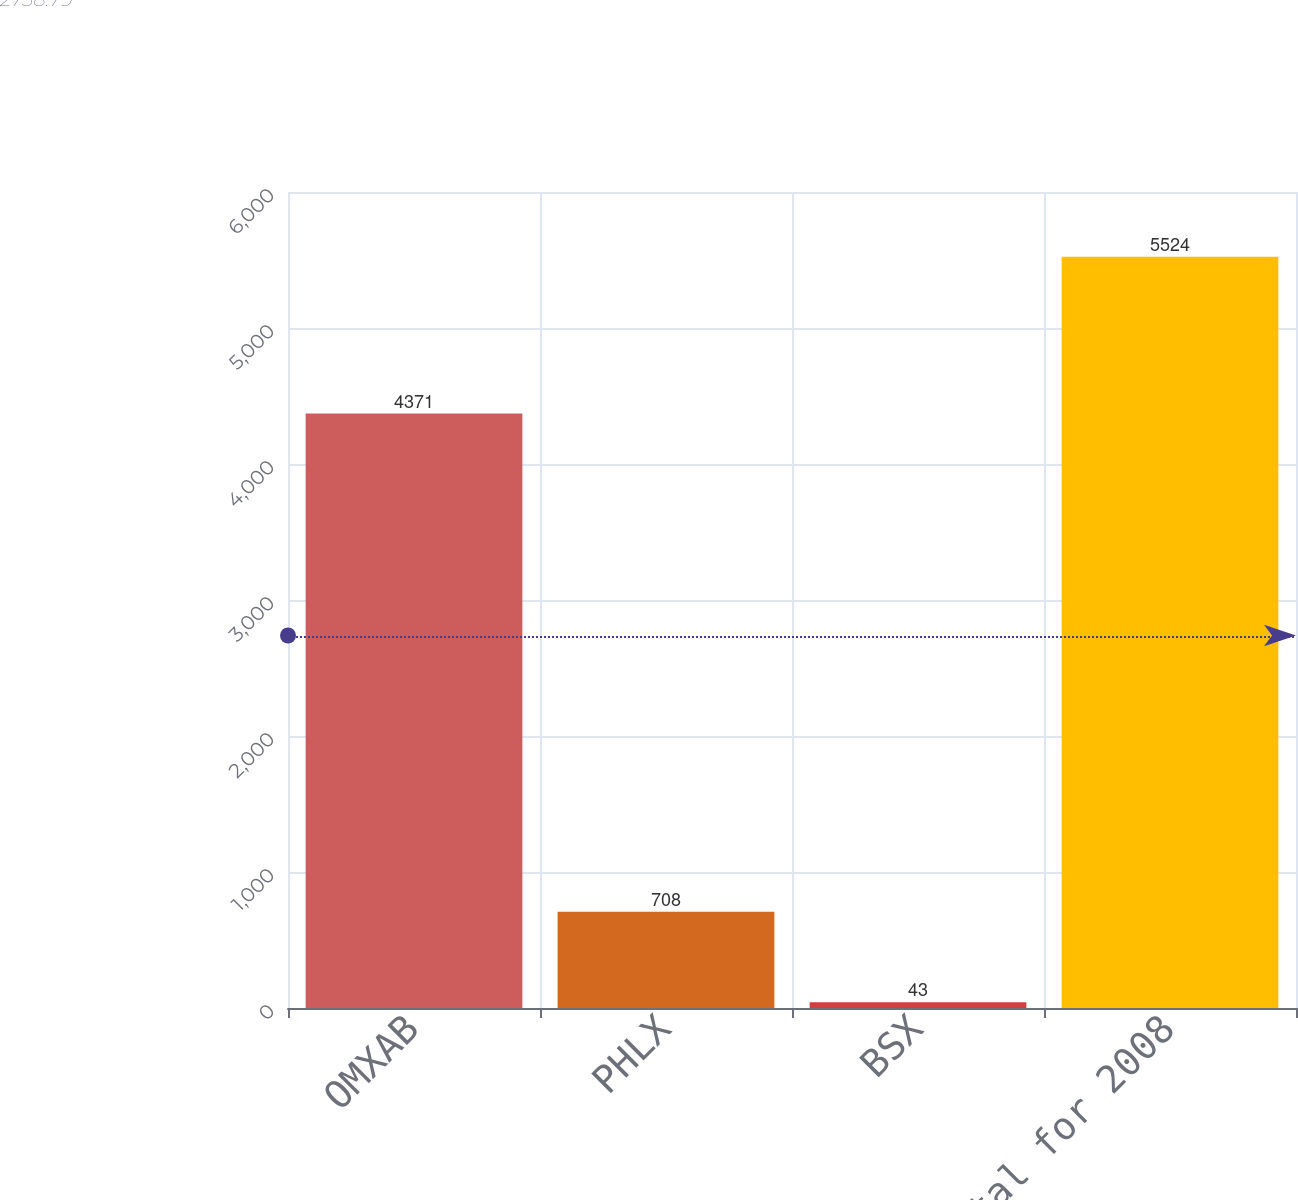<chart> <loc_0><loc_0><loc_500><loc_500><bar_chart><fcel>OMXAB<fcel>PHLX<fcel>BSX<fcel>Total for 2008<nl><fcel>4371<fcel>708<fcel>43<fcel>5524<nl></chart> 